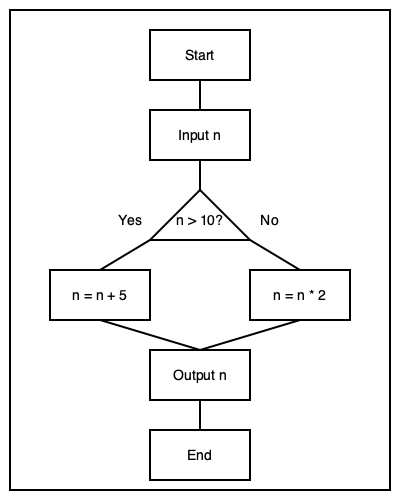As a software developer, analyze the flowchart representing a simple algorithm. If the input value of n is 15, what will be the output of this algorithm? Let's follow the flowchart step-by-step:

1. We start with the input n = 15.

2. The first decision point asks if n > 10.
   15 > 10, so the answer is Yes.

3. We follow the "Yes" path, which leads to "n = n + 5".
   n = 15 + 5 = 20

4. After this operation, we move to the "Output n" step.

5. The final value of n (20) is output.

6. The algorithm ends.

Therefore, when the input value of n is 15, the output of this algorithm will be 20.
Answer: 20 